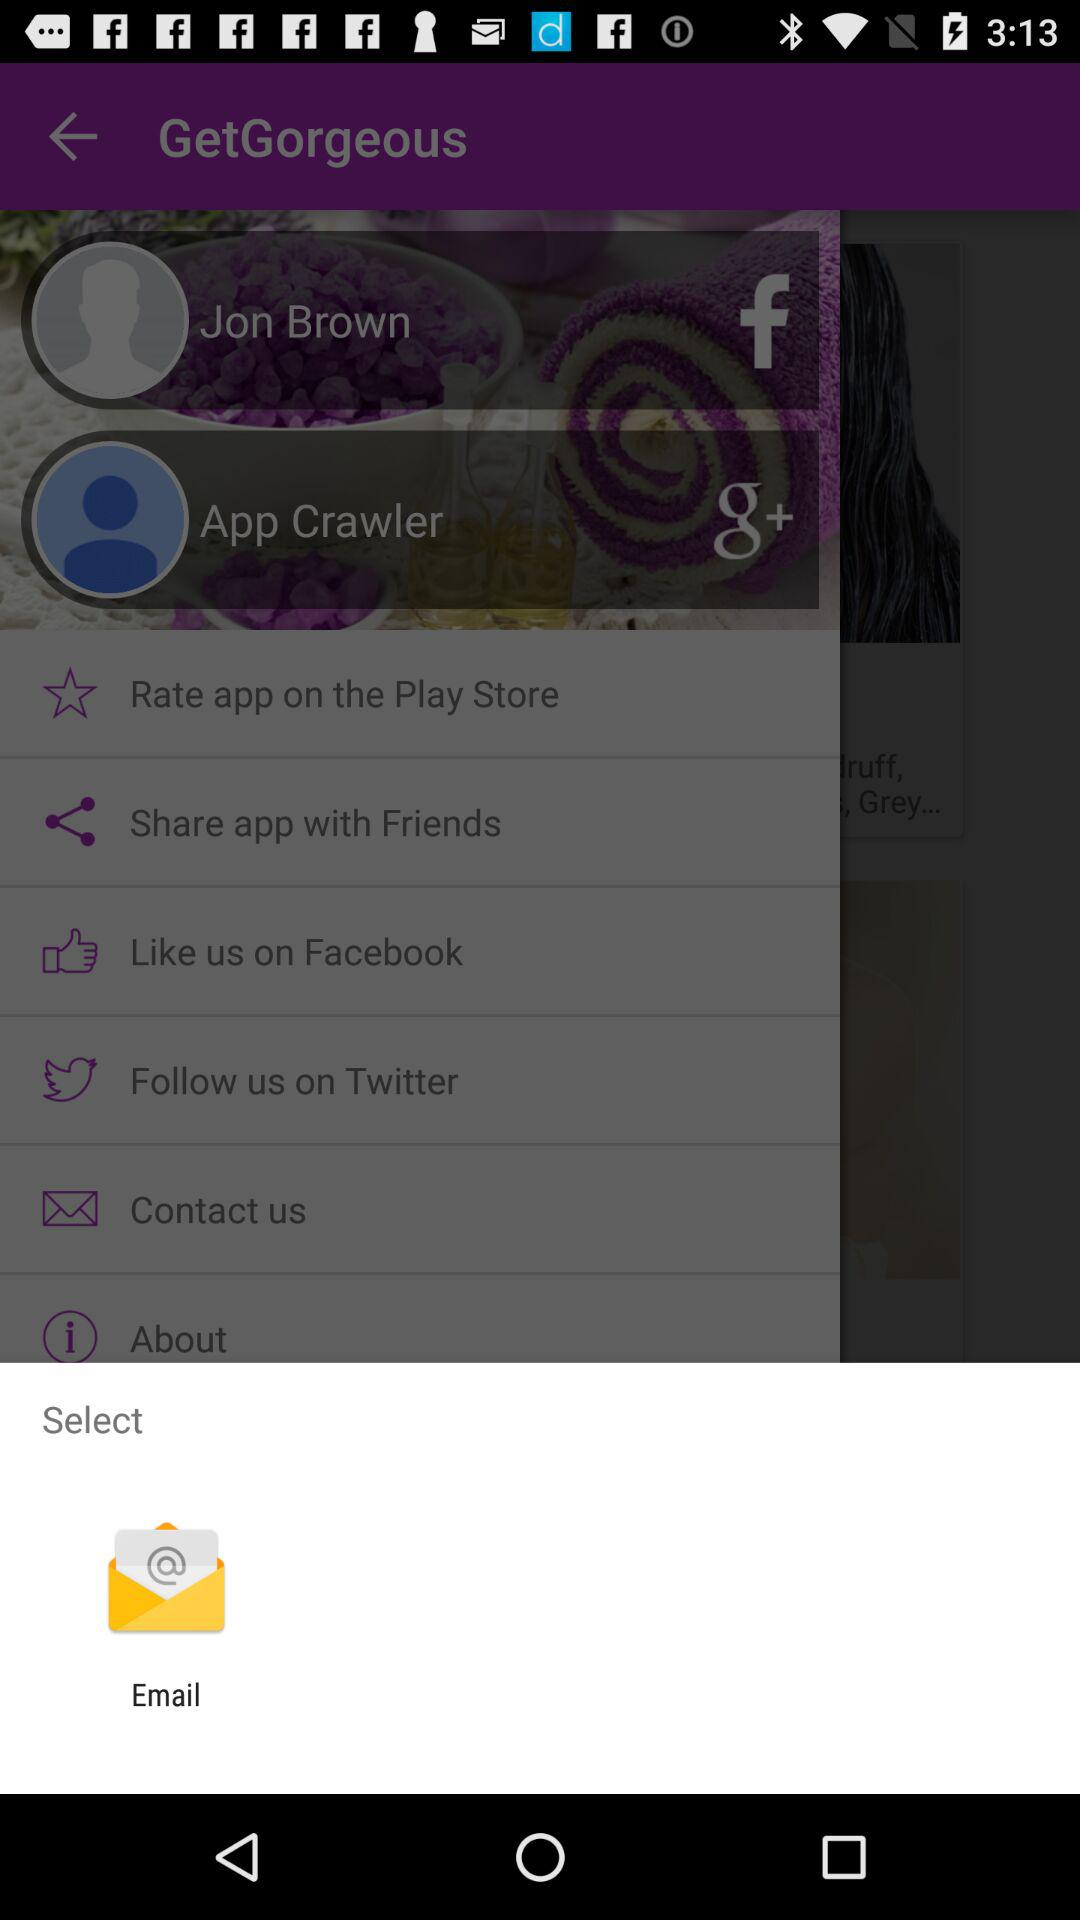What application is used to select? The application used to select is "Email". 